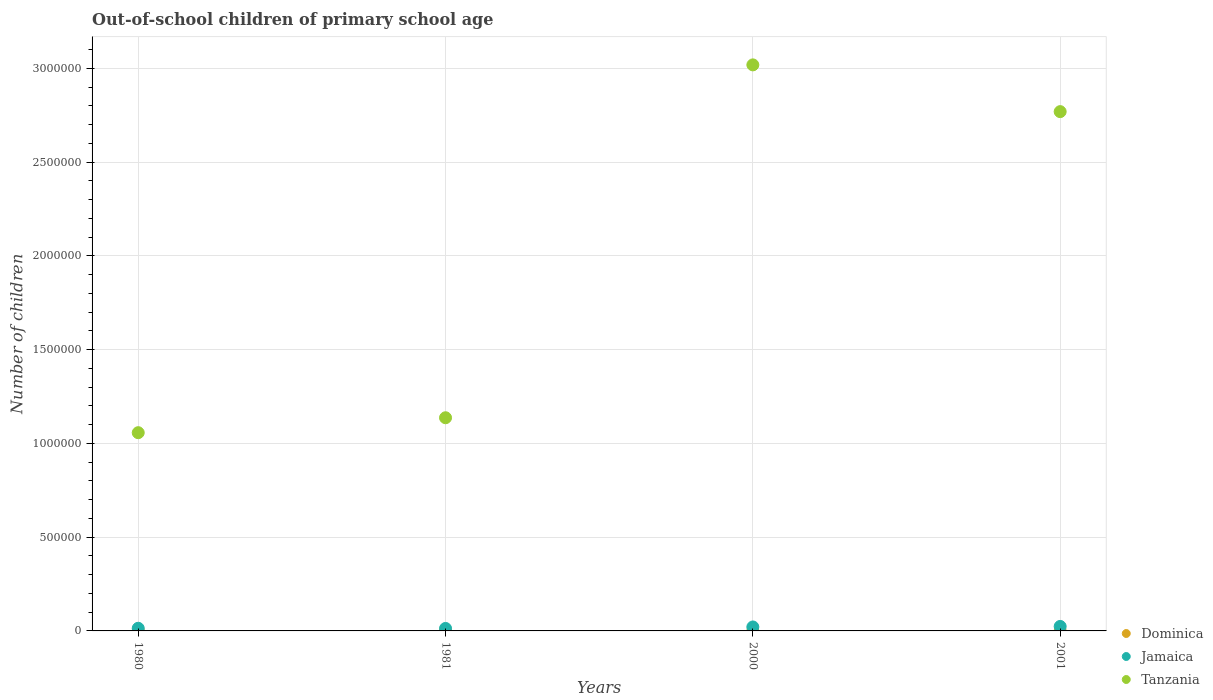What is the number of out-of-school children in Tanzania in 1981?
Keep it short and to the point. 1.14e+06. Across all years, what is the maximum number of out-of-school children in Jamaica?
Your answer should be very brief. 2.40e+04. Across all years, what is the minimum number of out-of-school children in Tanzania?
Your response must be concise. 1.06e+06. In which year was the number of out-of-school children in Tanzania maximum?
Offer a very short reply. 2000. What is the total number of out-of-school children in Dominica in the graph?
Provide a short and direct response. 4837. What is the difference between the number of out-of-school children in Tanzania in 1980 and that in 2001?
Provide a short and direct response. -1.71e+06. What is the difference between the number of out-of-school children in Tanzania in 1981 and the number of out-of-school children in Dominica in 2000?
Your answer should be compact. 1.14e+06. What is the average number of out-of-school children in Dominica per year?
Your response must be concise. 1209.25. In the year 2001, what is the difference between the number of out-of-school children in Jamaica and number of out-of-school children in Tanzania?
Give a very brief answer. -2.75e+06. What is the ratio of the number of out-of-school children in Tanzania in 1981 to that in 2001?
Provide a succinct answer. 0.41. What is the difference between the highest and the second highest number of out-of-school children in Tanzania?
Ensure brevity in your answer.  2.49e+05. What is the difference between the highest and the lowest number of out-of-school children in Tanzania?
Your answer should be very brief. 1.96e+06. In how many years, is the number of out-of-school children in Dominica greater than the average number of out-of-school children in Dominica taken over all years?
Your answer should be very brief. 2. Is the sum of the number of out-of-school children in Tanzania in 1981 and 2000 greater than the maximum number of out-of-school children in Jamaica across all years?
Your answer should be compact. Yes. Does the number of out-of-school children in Tanzania monotonically increase over the years?
Keep it short and to the point. No. Is the number of out-of-school children in Tanzania strictly greater than the number of out-of-school children in Dominica over the years?
Your answer should be very brief. Yes. How many years are there in the graph?
Provide a succinct answer. 4. Where does the legend appear in the graph?
Your response must be concise. Bottom right. How many legend labels are there?
Provide a short and direct response. 3. How are the legend labels stacked?
Provide a succinct answer. Vertical. What is the title of the graph?
Give a very brief answer. Out-of-school children of primary school age. Does "Estonia" appear as one of the legend labels in the graph?
Ensure brevity in your answer.  No. What is the label or title of the Y-axis?
Provide a short and direct response. Number of children. What is the Number of children of Dominica in 1980?
Keep it short and to the point. 2120. What is the Number of children in Jamaica in 1980?
Make the answer very short. 1.41e+04. What is the Number of children in Tanzania in 1980?
Keep it short and to the point. 1.06e+06. What is the Number of children in Dominica in 1981?
Offer a very short reply. 2288. What is the Number of children in Jamaica in 1981?
Your answer should be compact. 1.32e+04. What is the Number of children of Tanzania in 1981?
Provide a short and direct response. 1.14e+06. What is the Number of children of Dominica in 2000?
Keep it short and to the point. 155. What is the Number of children in Jamaica in 2000?
Provide a succinct answer. 2.11e+04. What is the Number of children of Tanzania in 2000?
Offer a terse response. 3.02e+06. What is the Number of children in Dominica in 2001?
Your answer should be compact. 274. What is the Number of children of Jamaica in 2001?
Make the answer very short. 2.40e+04. What is the Number of children of Tanzania in 2001?
Your answer should be compact. 2.77e+06. Across all years, what is the maximum Number of children in Dominica?
Give a very brief answer. 2288. Across all years, what is the maximum Number of children of Jamaica?
Offer a terse response. 2.40e+04. Across all years, what is the maximum Number of children in Tanzania?
Offer a very short reply. 3.02e+06. Across all years, what is the minimum Number of children of Dominica?
Keep it short and to the point. 155. Across all years, what is the minimum Number of children in Jamaica?
Give a very brief answer. 1.32e+04. Across all years, what is the minimum Number of children in Tanzania?
Keep it short and to the point. 1.06e+06. What is the total Number of children of Dominica in the graph?
Your answer should be compact. 4837. What is the total Number of children of Jamaica in the graph?
Offer a terse response. 7.24e+04. What is the total Number of children of Tanzania in the graph?
Provide a succinct answer. 7.98e+06. What is the difference between the Number of children of Dominica in 1980 and that in 1981?
Your response must be concise. -168. What is the difference between the Number of children in Jamaica in 1980 and that in 1981?
Ensure brevity in your answer.  870. What is the difference between the Number of children in Tanzania in 1980 and that in 1981?
Your response must be concise. -7.97e+04. What is the difference between the Number of children in Dominica in 1980 and that in 2000?
Ensure brevity in your answer.  1965. What is the difference between the Number of children in Jamaica in 1980 and that in 2000?
Offer a terse response. -7031. What is the difference between the Number of children of Tanzania in 1980 and that in 2000?
Make the answer very short. -1.96e+06. What is the difference between the Number of children of Dominica in 1980 and that in 2001?
Offer a very short reply. 1846. What is the difference between the Number of children of Jamaica in 1980 and that in 2001?
Give a very brief answer. -9856. What is the difference between the Number of children of Tanzania in 1980 and that in 2001?
Make the answer very short. -1.71e+06. What is the difference between the Number of children of Dominica in 1981 and that in 2000?
Your response must be concise. 2133. What is the difference between the Number of children in Jamaica in 1981 and that in 2000?
Make the answer very short. -7901. What is the difference between the Number of children of Tanzania in 1981 and that in 2000?
Your response must be concise. -1.88e+06. What is the difference between the Number of children of Dominica in 1981 and that in 2001?
Give a very brief answer. 2014. What is the difference between the Number of children in Jamaica in 1981 and that in 2001?
Offer a very short reply. -1.07e+04. What is the difference between the Number of children of Tanzania in 1981 and that in 2001?
Offer a terse response. -1.63e+06. What is the difference between the Number of children of Dominica in 2000 and that in 2001?
Offer a terse response. -119. What is the difference between the Number of children in Jamaica in 2000 and that in 2001?
Give a very brief answer. -2825. What is the difference between the Number of children in Tanzania in 2000 and that in 2001?
Ensure brevity in your answer.  2.49e+05. What is the difference between the Number of children of Dominica in 1980 and the Number of children of Jamaica in 1981?
Your answer should be very brief. -1.11e+04. What is the difference between the Number of children in Dominica in 1980 and the Number of children in Tanzania in 1981?
Make the answer very short. -1.13e+06. What is the difference between the Number of children in Jamaica in 1980 and the Number of children in Tanzania in 1981?
Offer a terse response. -1.12e+06. What is the difference between the Number of children of Dominica in 1980 and the Number of children of Jamaica in 2000?
Your answer should be very brief. -1.90e+04. What is the difference between the Number of children of Dominica in 1980 and the Number of children of Tanzania in 2000?
Provide a succinct answer. -3.02e+06. What is the difference between the Number of children of Jamaica in 1980 and the Number of children of Tanzania in 2000?
Offer a very short reply. -3.01e+06. What is the difference between the Number of children of Dominica in 1980 and the Number of children of Jamaica in 2001?
Offer a very short reply. -2.18e+04. What is the difference between the Number of children in Dominica in 1980 and the Number of children in Tanzania in 2001?
Offer a terse response. -2.77e+06. What is the difference between the Number of children in Jamaica in 1980 and the Number of children in Tanzania in 2001?
Your answer should be compact. -2.76e+06. What is the difference between the Number of children of Dominica in 1981 and the Number of children of Jamaica in 2000?
Make the answer very short. -1.88e+04. What is the difference between the Number of children of Dominica in 1981 and the Number of children of Tanzania in 2000?
Make the answer very short. -3.02e+06. What is the difference between the Number of children in Jamaica in 1981 and the Number of children in Tanzania in 2000?
Ensure brevity in your answer.  -3.01e+06. What is the difference between the Number of children in Dominica in 1981 and the Number of children in Jamaica in 2001?
Ensure brevity in your answer.  -2.17e+04. What is the difference between the Number of children in Dominica in 1981 and the Number of children in Tanzania in 2001?
Offer a terse response. -2.77e+06. What is the difference between the Number of children of Jamaica in 1981 and the Number of children of Tanzania in 2001?
Offer a very short reply. -2.76e+06. What is the difference between the Number of children of Dominica in 2000 and the Number of children of Jamaica in 2001?
Your response must be concise. -2.38e+04. What is the difference between the Number of children in Dominica in 2000 and the Number of children in Tanzania in 2001?
Make the answer very short. -2.77e+06. What is the difference between the Number of children of Jamaica in 2000 and the Number of children of Tanzania in 2001?
Your response must be concise. -2.75e+06. What is the average Number of children of Dominica per year?
Ensure brevity in your answer.  1209.25. What is the average Number of children in Jamaica per year?
Your response must be concise. 1.81e+04. What is the average Number of children of Tanzania per year?
Your answer should be compact. 2.00e+06. In the year 1980, what is the difference between the Number of children in Dominica and Number of children in Jamaica?
Provide a short and direct response. -1.20e+04. In the year 1980, what is the difference between the Number of children of Dominica and Number of children of Tanzania?
Provide a short and direct response. -1.06e+06. In the year 1980, what is the difference between the Number of children in Jamaica and Number of children in Tanzania?
Ensure brevity in your answer.  -1.04e+06. In the year 1981, what is the difference between the Number of children of Dominica and Number of children of Jamaica?
Provide a succinct answer. -1.09e+04. In the year 1981, what is the difference between the Number of children in Dominica and Number of children in Tanzania?
Your answer should be compact. -1.13e+06. In the year 1981, what is the difference between the Number of children of Jamaica and Number of children of Tanzania?
Provide a succinct answer. -1.12e+06. In the year 2000, what is the difference between the Number of children in Dominica and Number of children in Jamaica?
Offer a very short reply. -2.10e+04. In the year 2000, what is the difference between the Number of children in Dominica and Number of children in Tanzania?
Provide a short and direct response. -3.02e+06. In the year 2000, what is the difference between the Number of children of Jamaica and Number of children of Tanzania?
Your response must be concise. -3.00e+06. In the year 2001, what is the difference between the Number of children in Dominica and Number of children in Jamaica?
Your response must be concise. -2.37e+04. In the year 2001, what is the difference between the Number of children of Dominica and Number of children of Tanzania?
Your answer should be very brief. -2.77e+06. In the year 2001, what is the difference between the Number of children in Jamaica and Number of children in Tanzania?
Make the answer very short. -2.75e+06. What is the ratio of the Number of children of Dominica in 1980 to that in 1981?
Ensure brevity in your answer.  0.93. What is the ratio of the Number of children in Jamaica in 1980 to that in 1981?
Your response must be concise. 1.07. What is the ratio of the Number of children of Tanzania in 1980 to that in 1981?
Your answer should be very brief. 0.93. What is the ratio of the Number of children in Dominica in 1980 to that in 2000?
Ensure brevity in your answer.  13.68. What is the ratio of the Number of children in Jamaica in 1980 to that in 2000?
Your answer should be compact. 0.67. What is the ratio of the Number of children in Tanzania in 1980 to that in 2000?
Your response must be concise. 0.35. What is the ratio of the Number of children in Dominica in 1980 to that in 2001?
Your answer should be compact. 7.74. What is the ratio of the Number of children in Jamaica in 1980 to that in 2001?
Offer a terse response. 0.59. What is the ratio of the Number of children of Tanzania in 1980 to that in 2001?
Provide a succinct answer. 0.38. What is the ratio of the Number of children of Dominica in 1981 to that in 2000?
Your answer should be very brief. 14.76. What is the ratio of the Number of children of Jamaica in 1981 to that in 2000?
Offer a terse response. 0.63. What is the ratio of the Number of children of Tanzania in 1981 to that in 2000?
Keep it short and to the point. 0.38. What is the ratio of the Number of children in Dominica in 1981 to that in 2001?
Your answer should be compact. 8.35. What is the ratio of the Number of children of Jamaica in 1981 to that in 2001?
Offer a terse response. 0.55. What is the ratio of the Number of children in Tanzania in 1981 to that in 2001?
Keep it short and to the point. 0.41. What is the ratio of the Number of children of Dominica in 2000 to that in 2001?
Your answer should be compact. 0.57. What is the ratio of the Number of children of Jamaica in 2000 to that in 2001?
Give a very brief answer. 0.88. What is the ratio of the Number of children of Tanzania in 2000 to that in 2001?
Give a very brief answer. 1.09. What is the difference between the highest and the second highest Number of children in Dominica?
Provide a short and direct response. 168. What is the difference between the highest and the second highest Number of children of Jamaica?
Make the answer very short. 2825. What is the difference between the highest and the second highest Number of children in Tanzania?
Your response must be concise. 2.49e+05. What is the difference between the highest and the lowest Number of children in Dominica?
Keep it short and to the point. 2133. What is the difference between the highest and the lowest Number of children of Jamaica?
Your answer should be compact. 1.07e+04. What is the difference between the highest and the lowest Number of children of Tanzania?
Make the answer very short. 1.96e+06. 